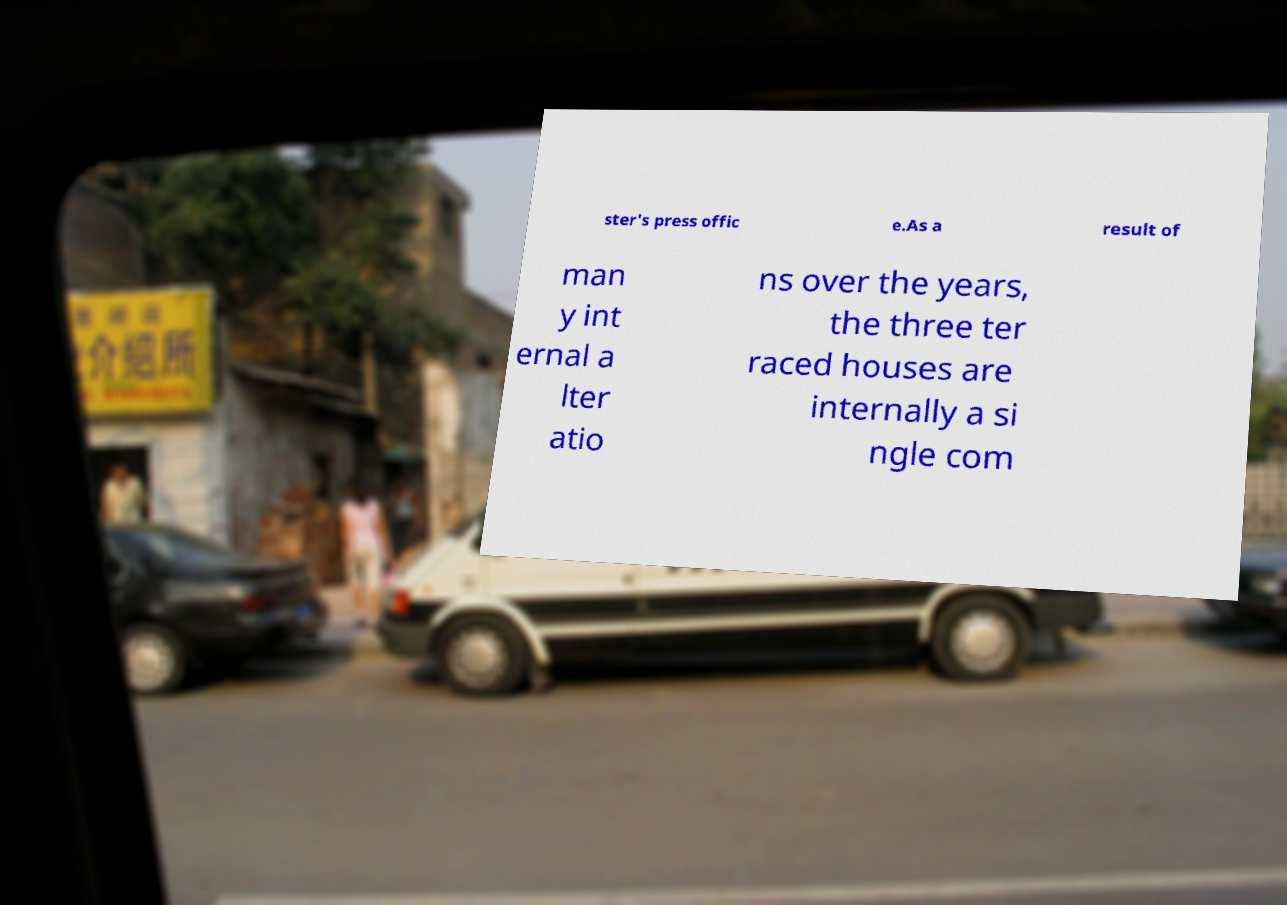Could you assist in decoding the text presented in this image and type it out clearly? ster's press offic e.As a result of man y int ernal a lter atio ns over the years, the three ter raced houses are internally a si ngle com 